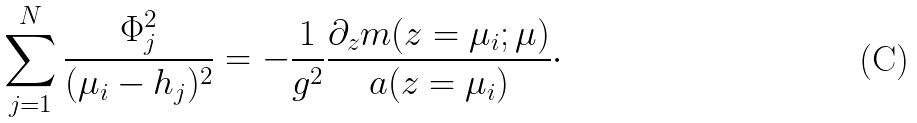Convert formula to latex. <formula><loc_0><loc_0><loc_500><loc_500>\sum _ { j = 1 } ^ { N } \frac { \Phi _ { j } ^ { 2 } } { ( \mu _ { i } - h _ { j } ) ^ { 2 } } = - \frac { 1 } { g ^ { 2 } } \frac { \partial _ { z } m ( z = \mu _ { i } ; \mu ) } { a ( z = \mu _ { i } ) } \cdot</formula> 